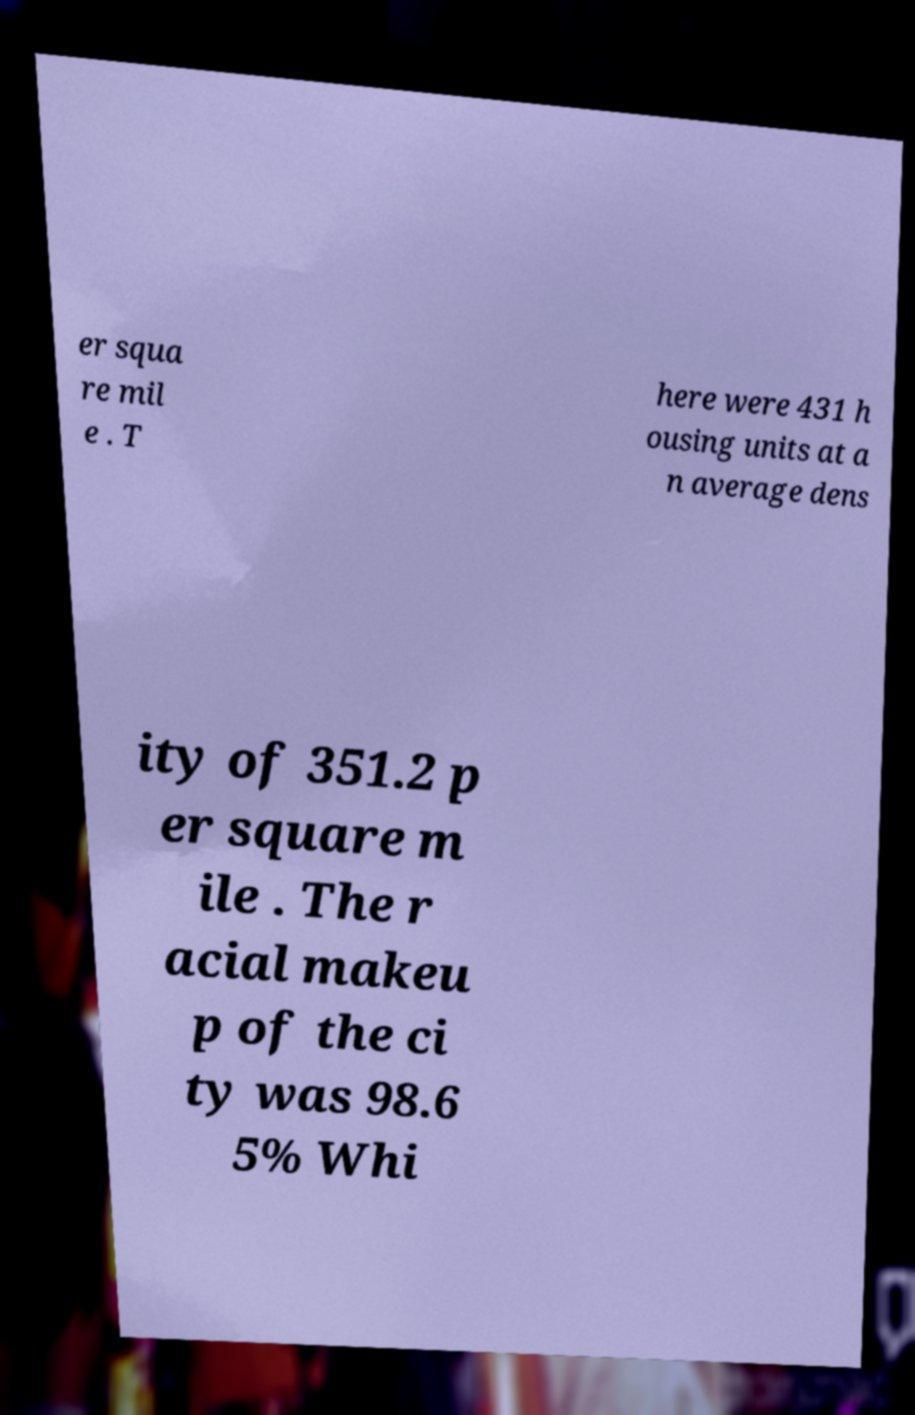Could you extract and type out the text from this image? er squa re mil e . T here were 431 h ousing units at a n average dens ity of 351.2 p er square m ile . The r acial makeu p of the ci ty was 98.6 5% Whi 